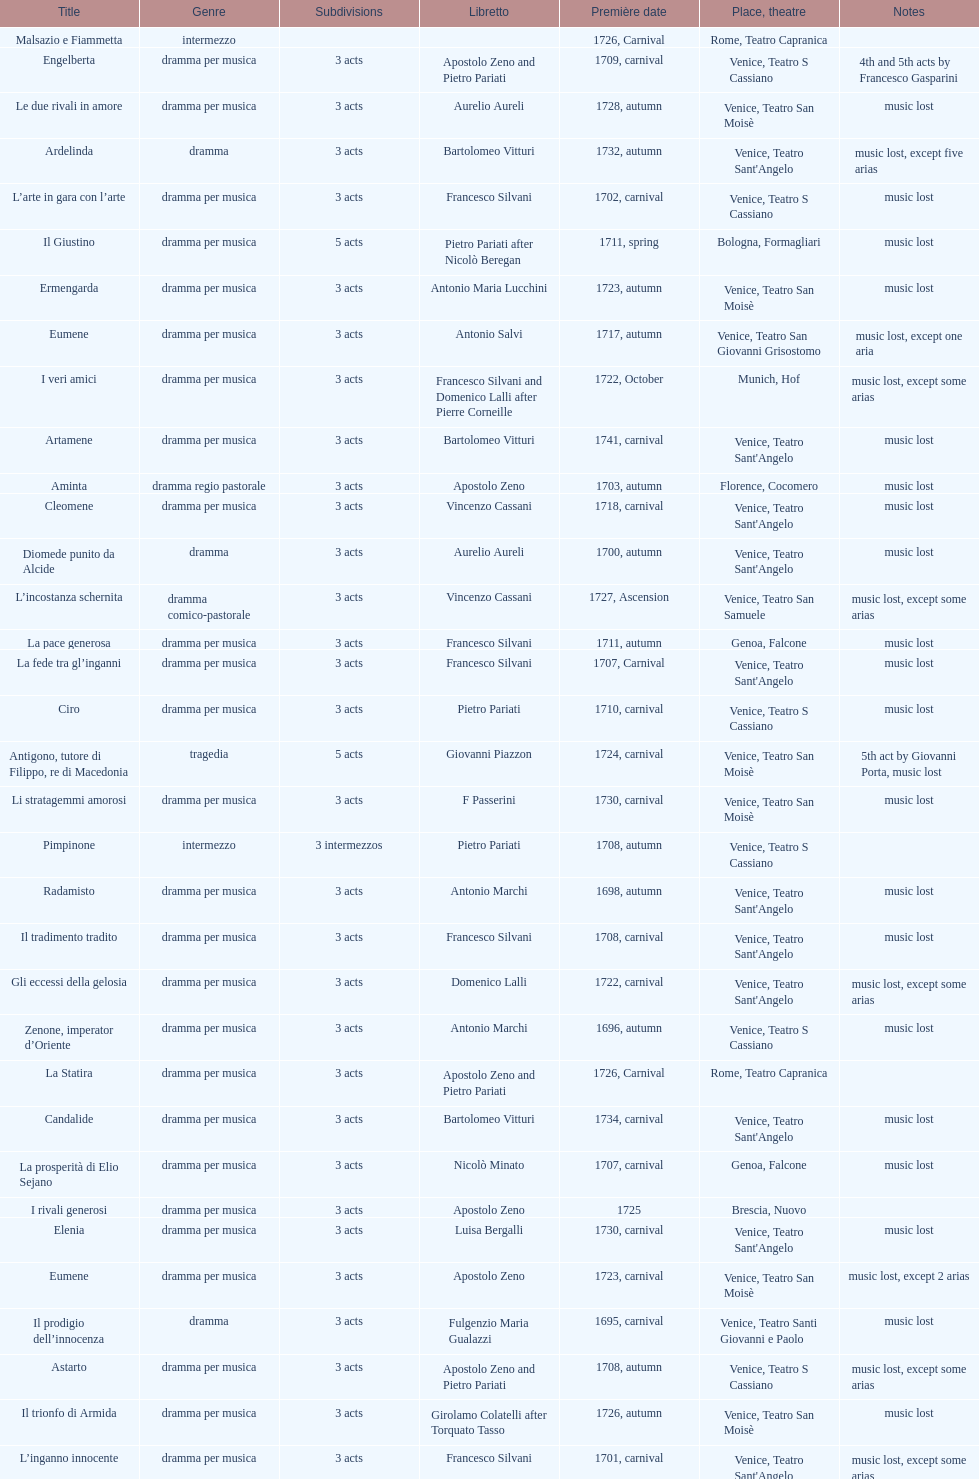What is next after ardelinda? Candalide. 